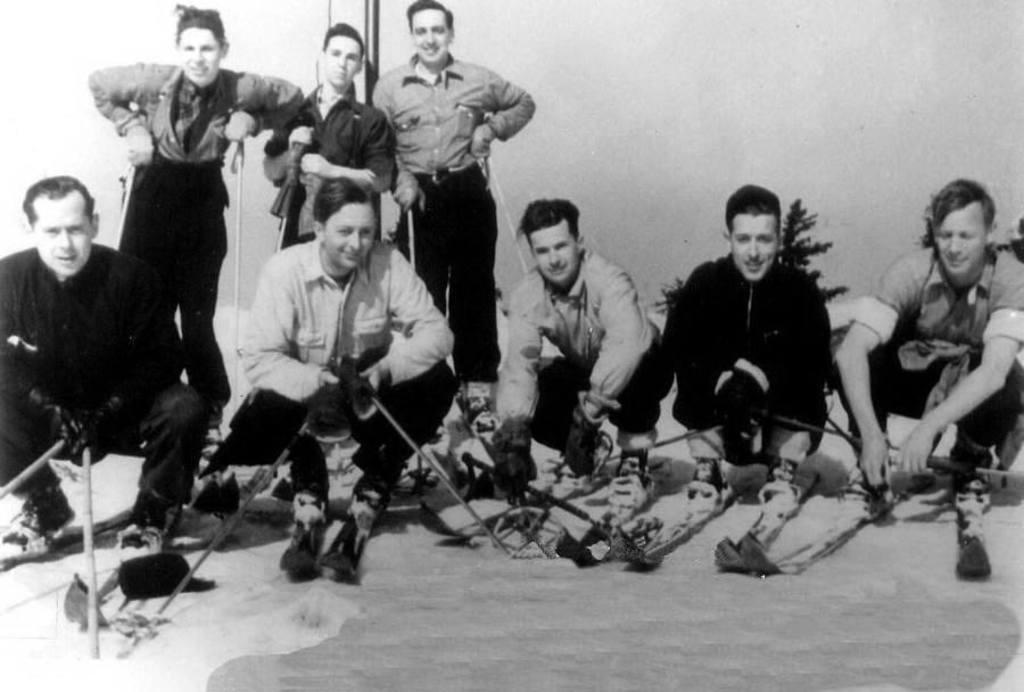What are the people in the image doing? The people in the image are holding a stick. What else can be seen in the image besides the people? There is a plant in the image, and it has a white background. What is the purpose of the rod in the image? The purpose of the rod in the image is not clear from the provided facts. What type of lamp is being used by the minister in the image? There is no minister or lamp present in the image. What fact is being discussed by the people in the image? The provided facts do not mention any specific fact being discussed by the people in the image. 